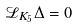<formula> <loc_0><loc_0><loc_500><loc_500>\mathcal { L } _ { K _ { 5 } } \Delta = 0</formula> 